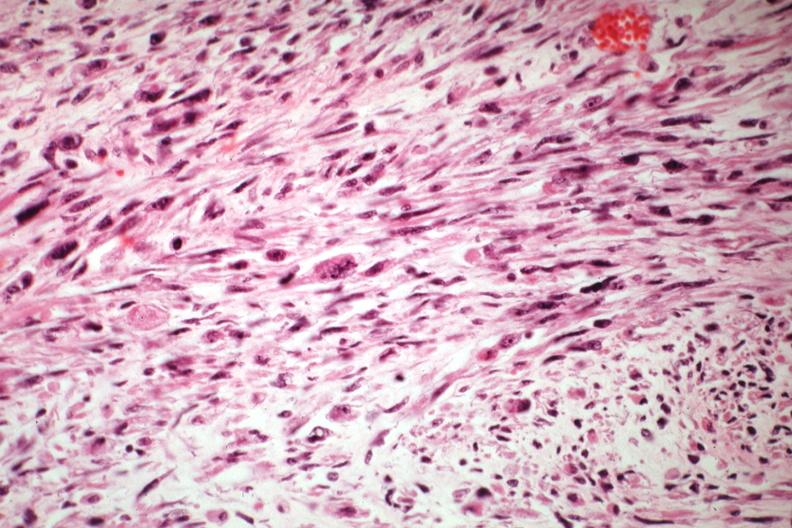does this image show bizarre strap and fusiform cells?
Answer the question using a single word or phrase. Yes 